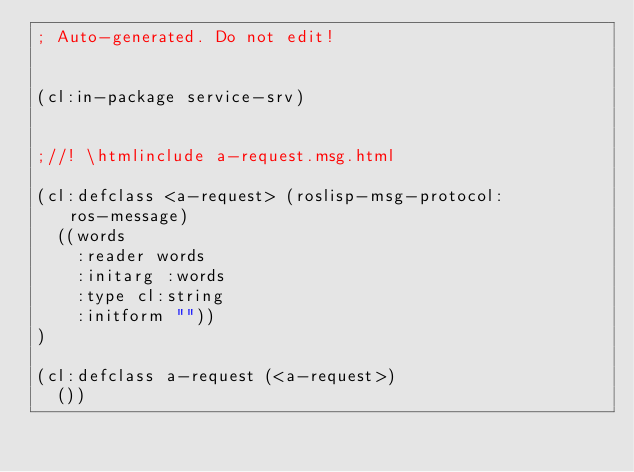<code> <loc_0><loc_0><loc_500><loc_500><_Lisp_>; Auto-generated. Do not edit!


(cl:in-package service-srv)


;//! \htmlinclude a-request.msg.html

(cl:defclass <a-request> (roslisp-msg-protocol:ros-message)
  ((words
    :reader words
    :initarg :words
    :type cl:string
    :initform ""))
)

(cl:defclass a-request (<a-request>)
  ())
</code> 